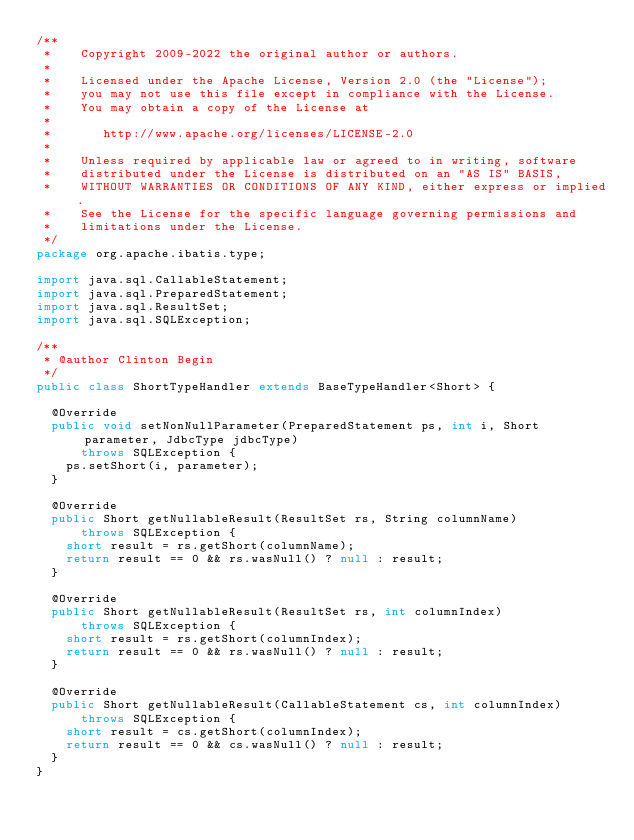<code> <loc_0><loc_0><loc_500><loc_500><_Java_>/**
 *    Copyright 2009-2022 the original author or authors.
 *
 *    Licensed under the Apache License, Version 2.0 (the "License");
 *    you may not use this file except in compliance with the License.
 *    You may obtain a copy of the License at
 *
 *       http://www.apache.org/licenses/LICENSE-2.0
 *
 *    Unless required by applicable law or agreed to in writing, software
 *    distributed under the License is distributed on an "AS IS" BASIS,
 *    WITHOUT WARRANTIES OR CONDITIONS OF ANY KIND, either express or implied.
 *    See the License for the specific language governing permissions and
 *    limitations under the License.
 */
package org.apache.ibatis.type;

import java.sql.CallableStatement;
import java.sql.PreparedStatement;
import java.sql.ResultSet;
import java.sql.SQLException;

/**
 * @author Clinton Begin
 */
public class ShortTypeHandler extends BaseTypeHandler<Short> {

  @Override
  public void setNonNullParameter(PreparedStatement ps, int i, Short parameter, JdbcType jdbcType)
      throws SQLException {
    ps.setShort(i, parameter);
  }

  @Override
  public Short getNullableResult(ResultSet rs, String columnName)
      throws SQLException {
    short result = rs.getShort(columnName);
    return result == 0 && rs.wasNull() ? null : result;
  }

  @Override
  public Short getNullableResult(ResultSet rs, int columnIndex)
      throws SQLException {
    short result = rs.getShort(columnIndex);
    return result == 0 && rs.wasNull() ? null : result;
  }

  @Override
  public Short getNullableResult(CallableStatement cs, int columnIndex)
      throws SQLException {
    short result = cs.getShort(columnIndex);
    return result == 0 && cs.wasNull() ? null : result;
  }
}
</code> 